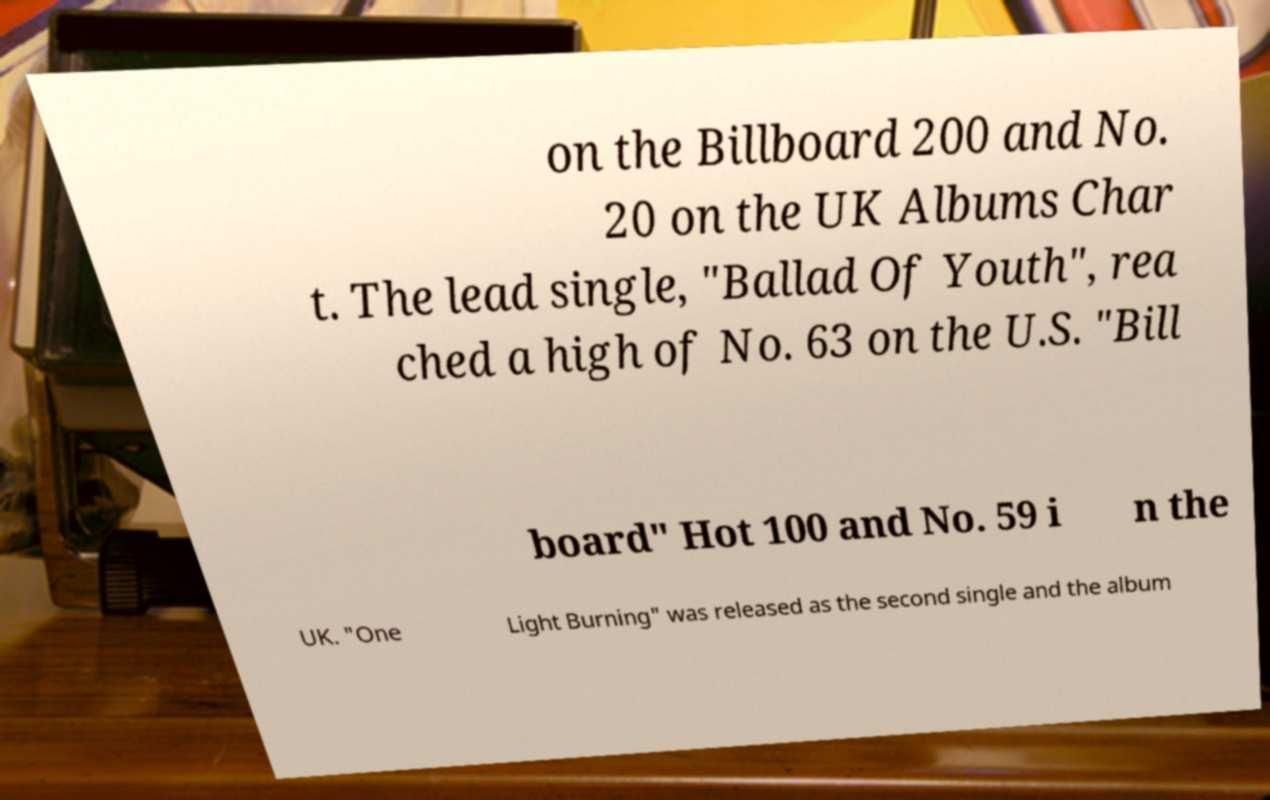Please identify and transcribe the text found in this image. on the Billboard 200 and No. 20 on the UK Albums Char t. The lead single, "Ballad Of Youth", rea ched a high of No. 63 on the U.S. "Bill board" Hot 100 and No. 59 i n the UK. "One Light Burning" was released as the second single and the album 